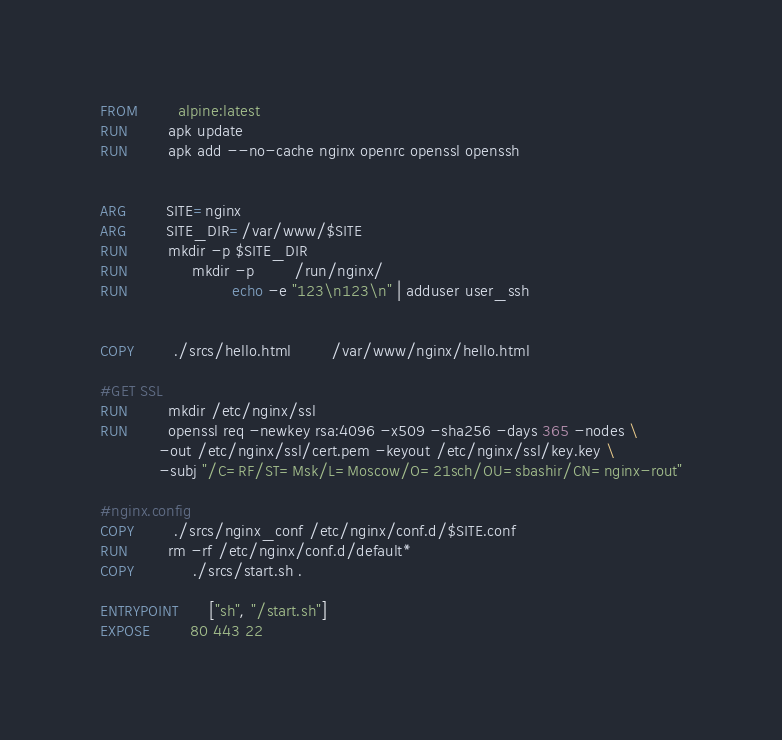<code> <loc_0><loc_0><loc_500><loc_500><_Dockerfile_>FROM 		alpine:latest
RUN 		apk update
RUN 		apk add --no-cache nginx openrc openssl openssh 


ARG 		SITE=nginx
ARG		SITE_DIR=/var/www/$SITE
RUN 		mkdir -p $SITE_DIR 
RUN             mkdir -p        /run/nginx/
RUN                     echo -e "123\n123\n" | adduser user_ssh


COPY 		./srcs/hello.html		/var/www/nginx/hello.html

#GET SSL
RUN		mkdir /etc/nginx/ssl
RUN		openssl req -newkey rsa:4096 -x509 -sha256 -days 365 -nodes \
			-out /etc/nginx/ssl/cert.pem -keyout /etc/nginx/ssl/key.key \
			-subj "/C=RF/ST=Msk/L=Moscow/O=21sch/OU=sbashir/CN=nginx-rout"

#nginx.config
COPY		./srcs/nginx_conf /etc/nginx/conf.d/$SITE.conf
RUN		rm -rf /etc/nginx/conf.d/default*
COPY            ./srcs/start.sh . 

ENTRYPOINT      ["sh", "/start.sh"]	
EXPOSE 		80 443 22
</code> 